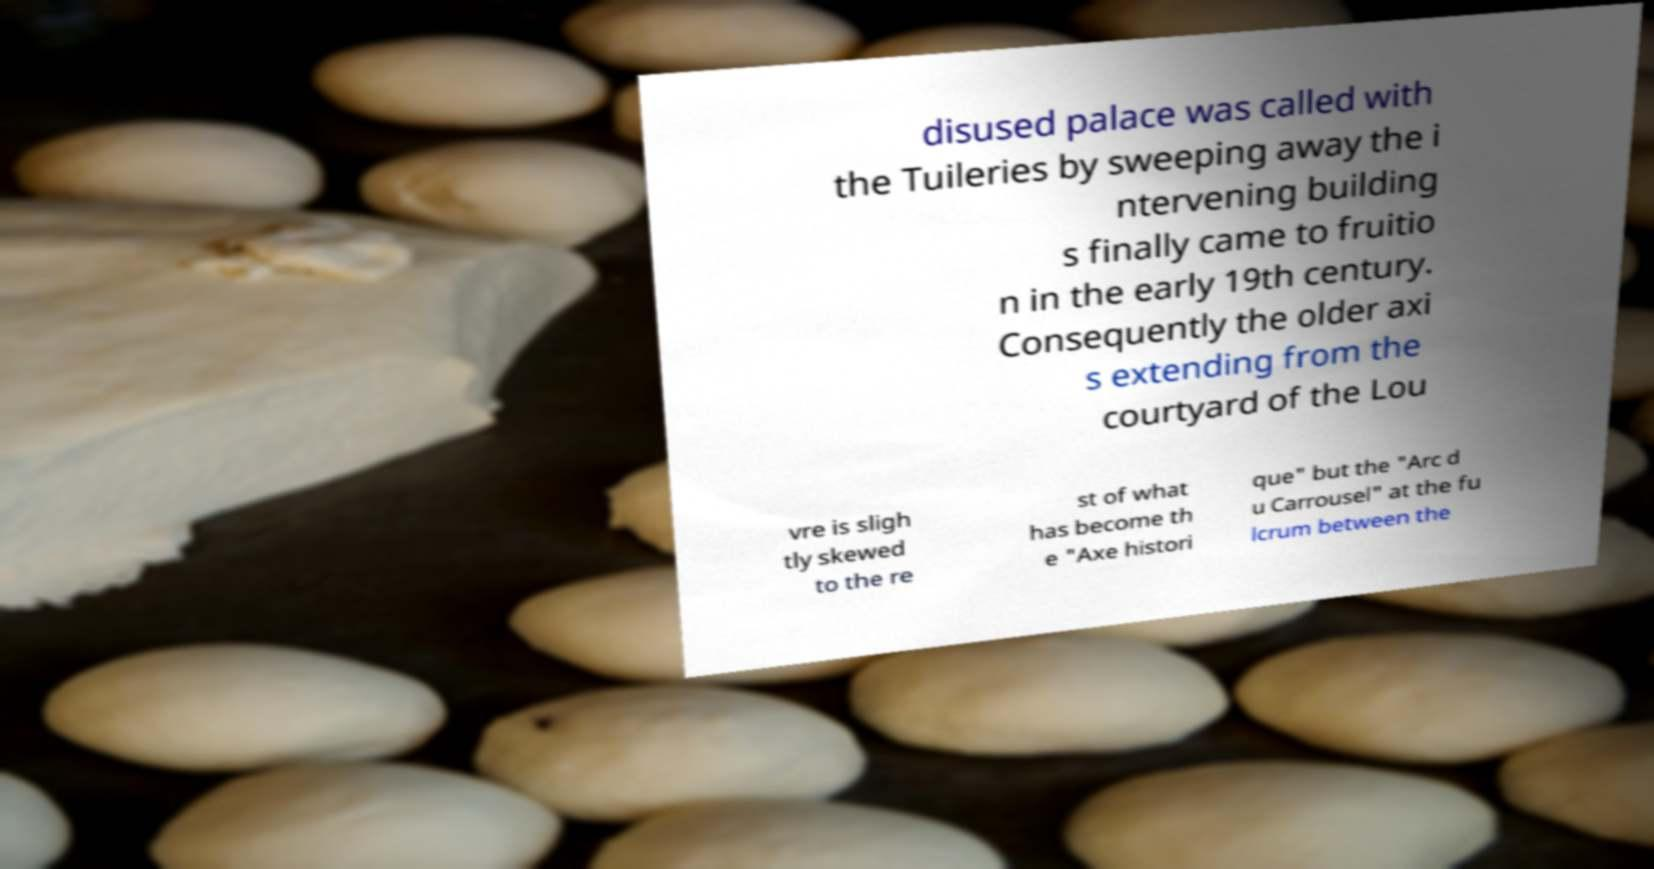For documentation purposes, I need the text within this image transcribed. Could you provide that? disused palace was called with the Tuileries by sweeping away the i ntervening building s finally came to fruitio n in the early 19th century. Consequently the older axi s extending from the courtyard of the Lou vre is sligh tly skewed to the re st of what has become th e "Axe histori que" but the "Arc d u Carrousel" at the fu lcrum between the 